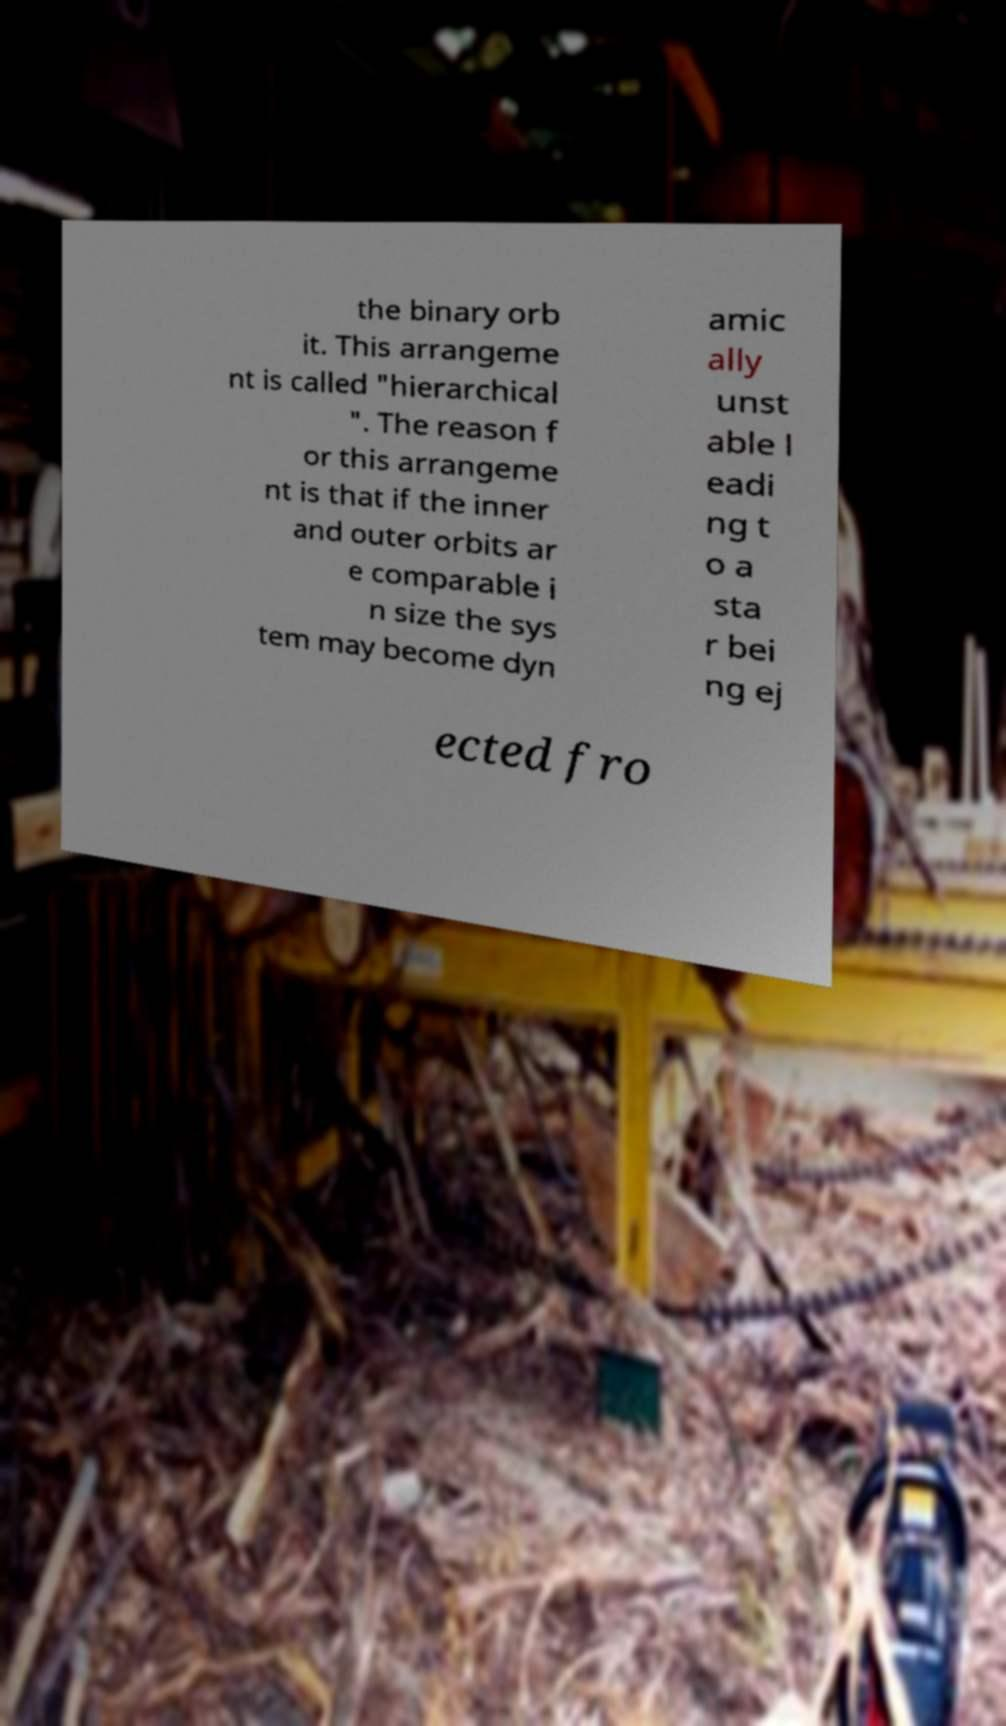Could you extract and type out the text from this image? the binary orb it. This arrangeme nt is called "hierarchical ". The reason f or this arrangeme nt is that if the inner and outer orbits ar e comparable i n size the sys tem may become dyn amic ally unst able l eadi ng t o a sta r bei ng ej ected fro 